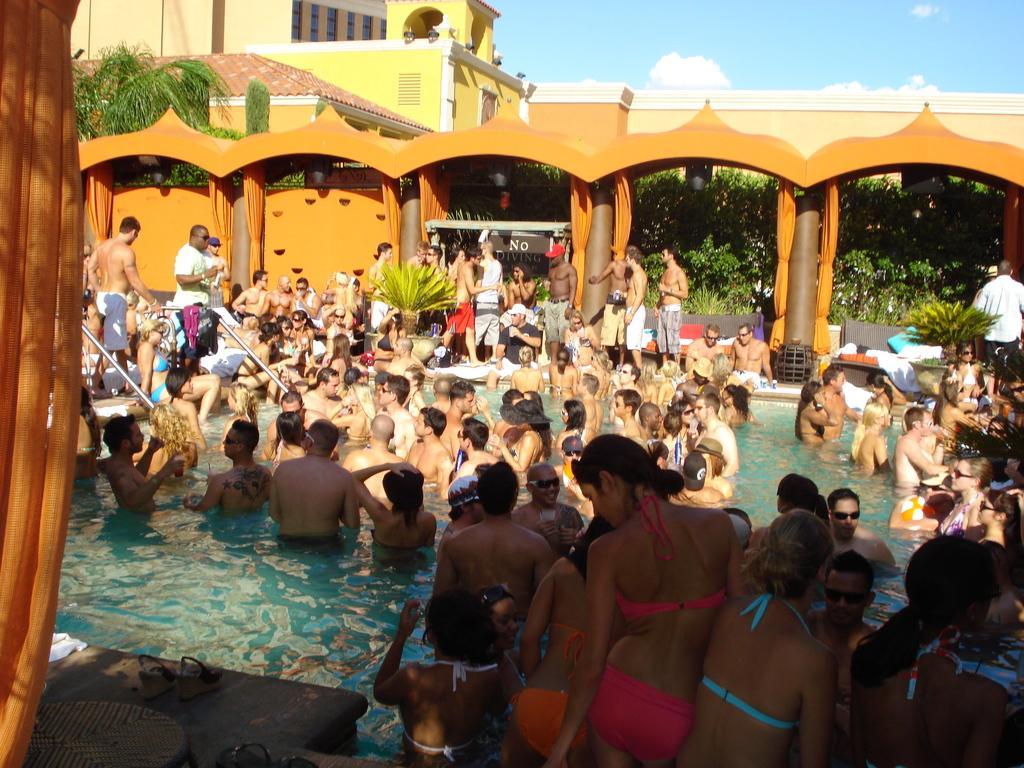In one or two sentences, can you explain what this image depicts? In this image I can see number of people in swimming pool. In the background I can see a building and number of trees. 